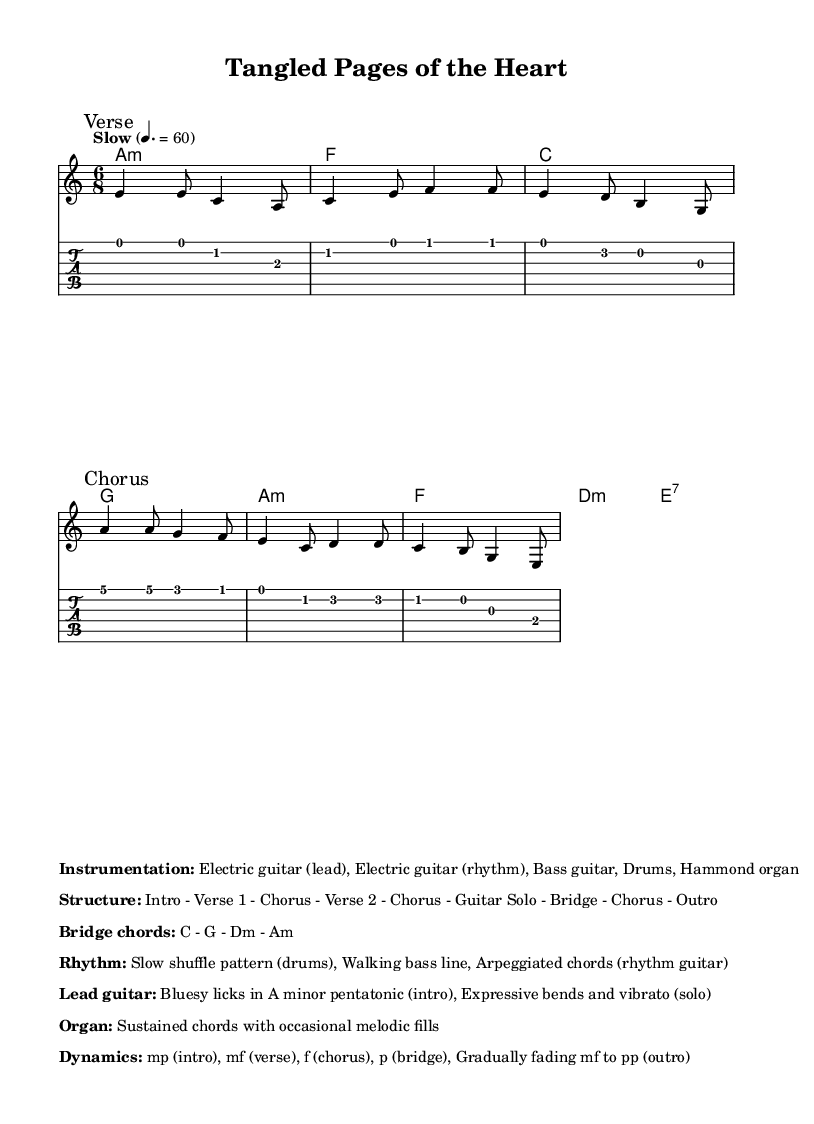What is the key signature of this music? The key signature is indicated at the beginning of the piece and shows two flats, which identifies it as A minor. This is also supported by the presence of A minor chords in the harmonic structure.
Answer: A minor What is the time signature of the piece? The time signature is displayed at the beginning of the sheet music, appearing as a '6/8', indicating that there are six eighth notes per measure, creating a flowing, triplet-like feel common in blues music.
Answer: 6/8 What is the tempo marking for the music? The tempo marking found at the start states "Slow" followed by "4. = 60," which indicates a slow pace at a speed of 60 beats per minute. This tempo sets a relaxed, introspective mood typical of electric blues ballads.
Answer: 60 What is the structure of the music? The structure is provided in the markup section at the bottom of the sheet music. It outlines how the piece is organized, starting with an intro followed by verses, choruses, a guitar solo, a bridge, and ending with an outro, characteristic of typical song forms.
Answer: Intro - Verse 1 - Chorus - Verse 2 - Chorus - Guitar Solo - Bridge - Chorus - Outro What type of rhythmic pattern is specified in the music? The rhythm section mentions a "Slow shuffle pattern" for the drums and a "Walking bass line," which are integral to the blues genre, giving it that signature groovy feel, enhancing both the instrumental and emotional drive of the piece.
Answer: Slow shuffle pattern What is included in the lead guitar's instructions? According to the markup, the lead guitar is instructed to play "Bluesy licks in A minor pentatonic" during the intro, adding expressive bends and vibrato in the solo, which are hallmark techniques in electric blues to convey deep emotion and feeling within the music.
Answer: Bluesy licks in A minor pentatonic What are the dynamics specified for the Outro? The dynamics for the outro are described as "Gradually fading mf to pp," indicating a smooth decrease in volume from moderately loud to very soft, creating an introspective and subtle finish to the piece that allows for reflective contemplation.
Answer: Gradually fading mf to pp 